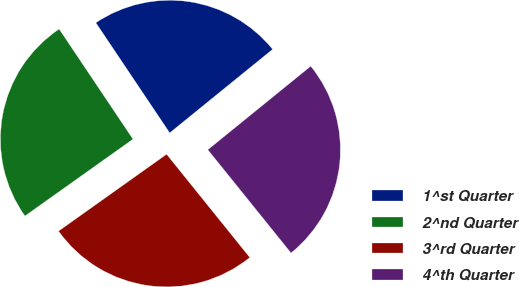Convert chart. <chart><loc_0><loc_0><loc_500><loc_500><pie_chart><fcel>1^st Quarter<fcel>2^nd Quarter<fcel>3^rd Quarter<fcel>4^th Quarter<nl><fcel>23.55%<fcel>25.44%<fcel>25.96%<fcel>25.06%<nl></chart> 